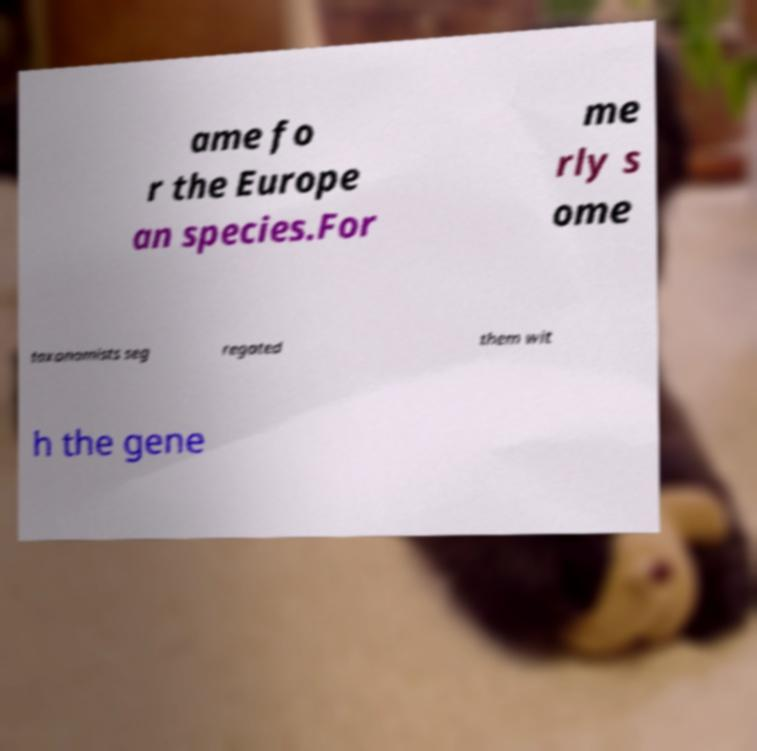Can you accurately transcribe the text from the provided image for me? ame fo r the Europe an species.For me rly s ome taxonomists seg regated them wit h the gene 